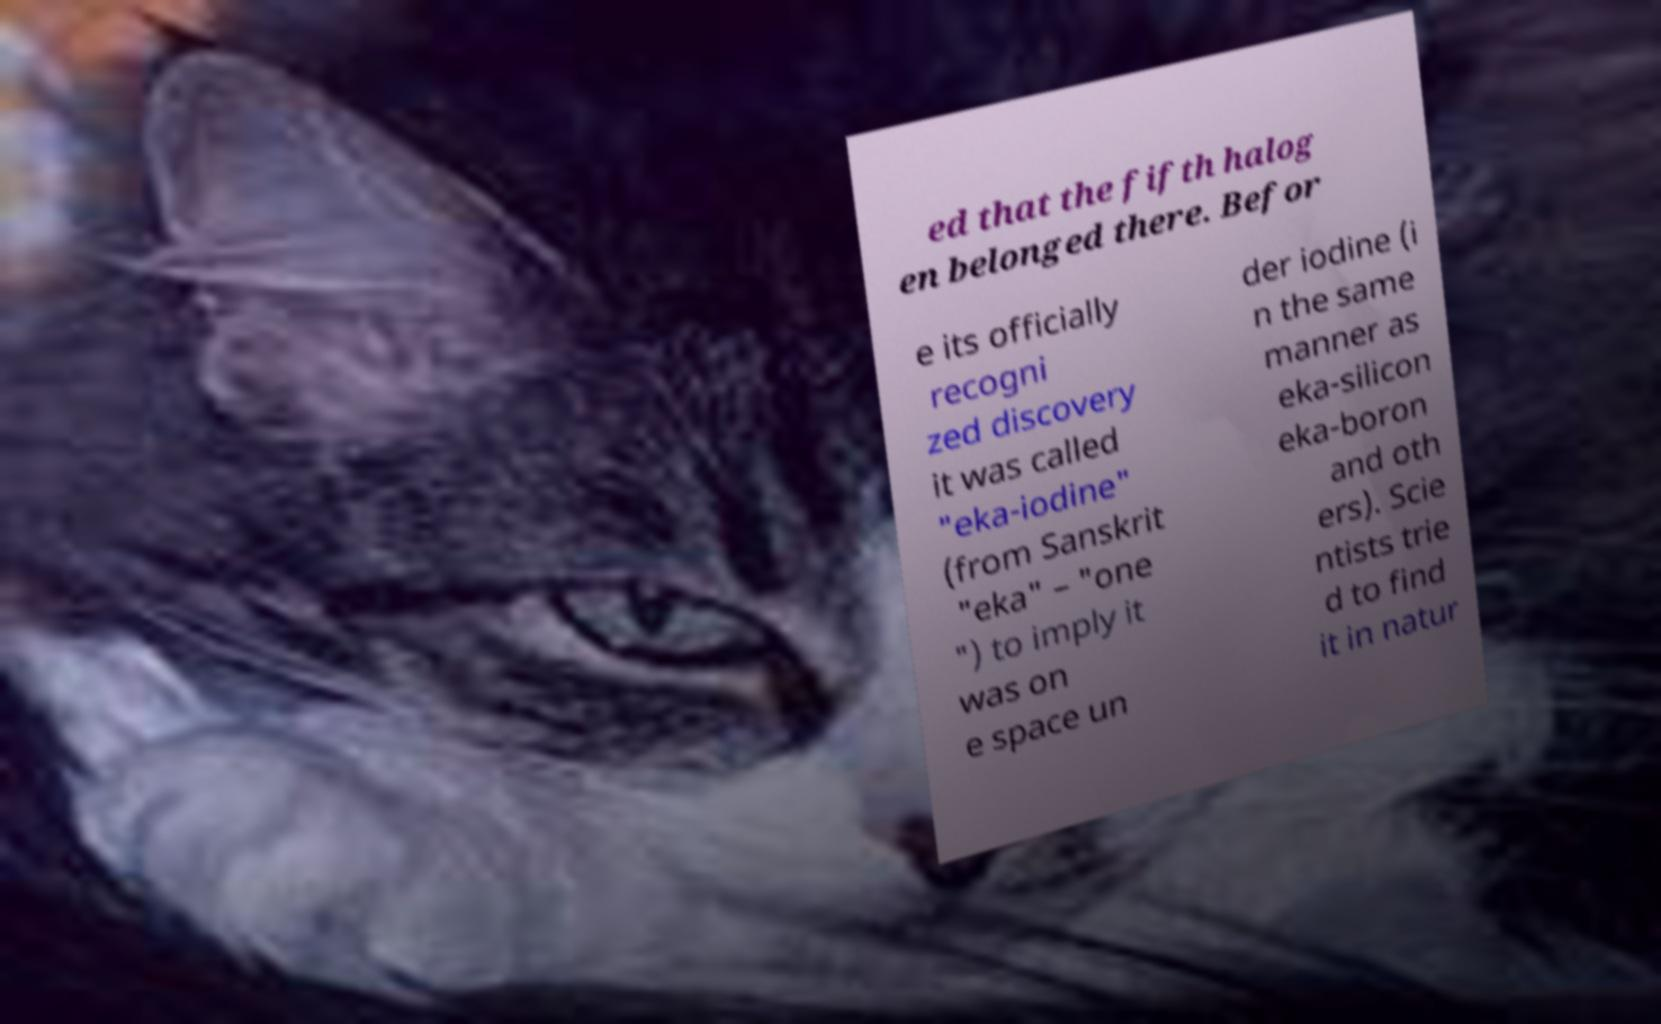What messages or text are displayed in this image? I need them in a readable, typed format. ed that the fifth halog en belonged there. Befor e its officially recogni zed discovery it was called "eka-iodine" (from Sanskrit "eka" – "one ") to imply it was on e space un der iodine (i n the same manner as eka-silicon eka-boron and oth ers). Scie ntists trie d to find it in natur 